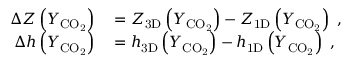Convert formula to latex. <formula><loc_0><loc_0><loc_500><loc_500>\begin{array} { r l } { \Delta Z \left ( Y _ { C O _ { 2 } } \right ) } & = Z _ { 3 D } \left ( Y _ { C O _ { 2 } } \right ) - Z _ { 1 D } \left ( Y _ { C O _ { 2 } } \right ) \ , } \\ { \Delta h \left ( Y _ { C O _ { 2 } } \right ) } & = h _ { 3 D } \left ( Y _ { C O _ { 2 } } \right ) - h _ { 1 D } \left ( Y _ { C O _ { 2 } } \right ) \ , } \end{array}</formula> 